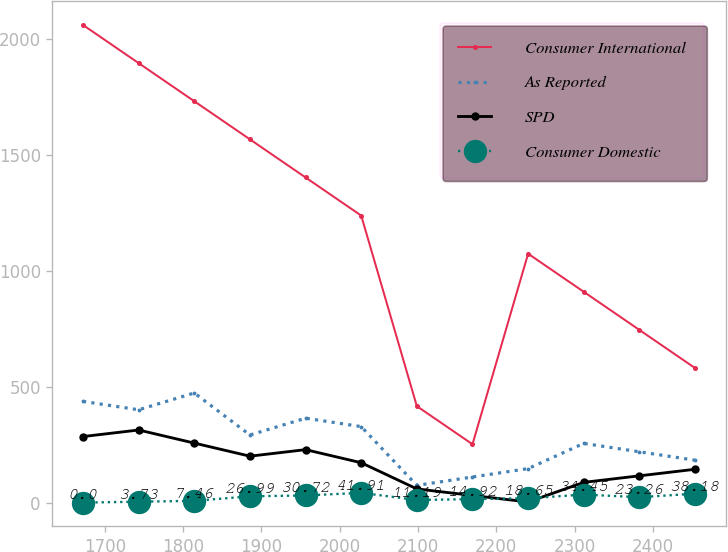Convert chart. <chart><loc_0><loc_0><loc_500><loc_500><line_chart><ecel><fcel>Consumer International<fcel>As Reported<fcel>SPD<fcel>Consumer Domestic<nl><fcel>1672.3<fcel>2058.28<fcel>436.13<fcel>284.58<fcel>0<nl><fcel>1743.35<fcel>1894.01<fcel>399.92<fcel>312.79<fcel>3.73<nl><fcel>1814.4<fcel>1729.74<fcel>472.34<fcel>256.37<fcel>7.46<nl><fcel>1885.45<fcel>1565.47<fcel>291.29<fcel>199.95<fcel>26.99<nl><fcel>1956.5<fcel>1401.2<fcel>363.71<fcel>228.16<fcel>30.72<nl><fcel>2027.55<fcel>1236.93<fcel>327.5<fcel>171.74<fcel>41.91<nl><fcel>2098.6<fcel>415.58<fcel>74.03<fcel>58.9<fcel>11.19<nl><fcel>2169.65<fcel>251.31<fcel>110.24<fcel>30.69<fcel>14.92<nl><fcel>2240.7<fcel>1072.66<fcel>146.45<fcel>2.48<fcel>18.65<nl><fcel>2311.75<fcel>908.39<fcel>255.08<fcel>87.11<fcel>34.45<nl><fcel>2382.8<fcel>744.12<fcel>218.87<fcel>115.32<fcel>23.26<nl><fcel>2453.85<fcel>579.85<fcel>182.66<fcel>143.53<fcel>38.18<nl></chart> 